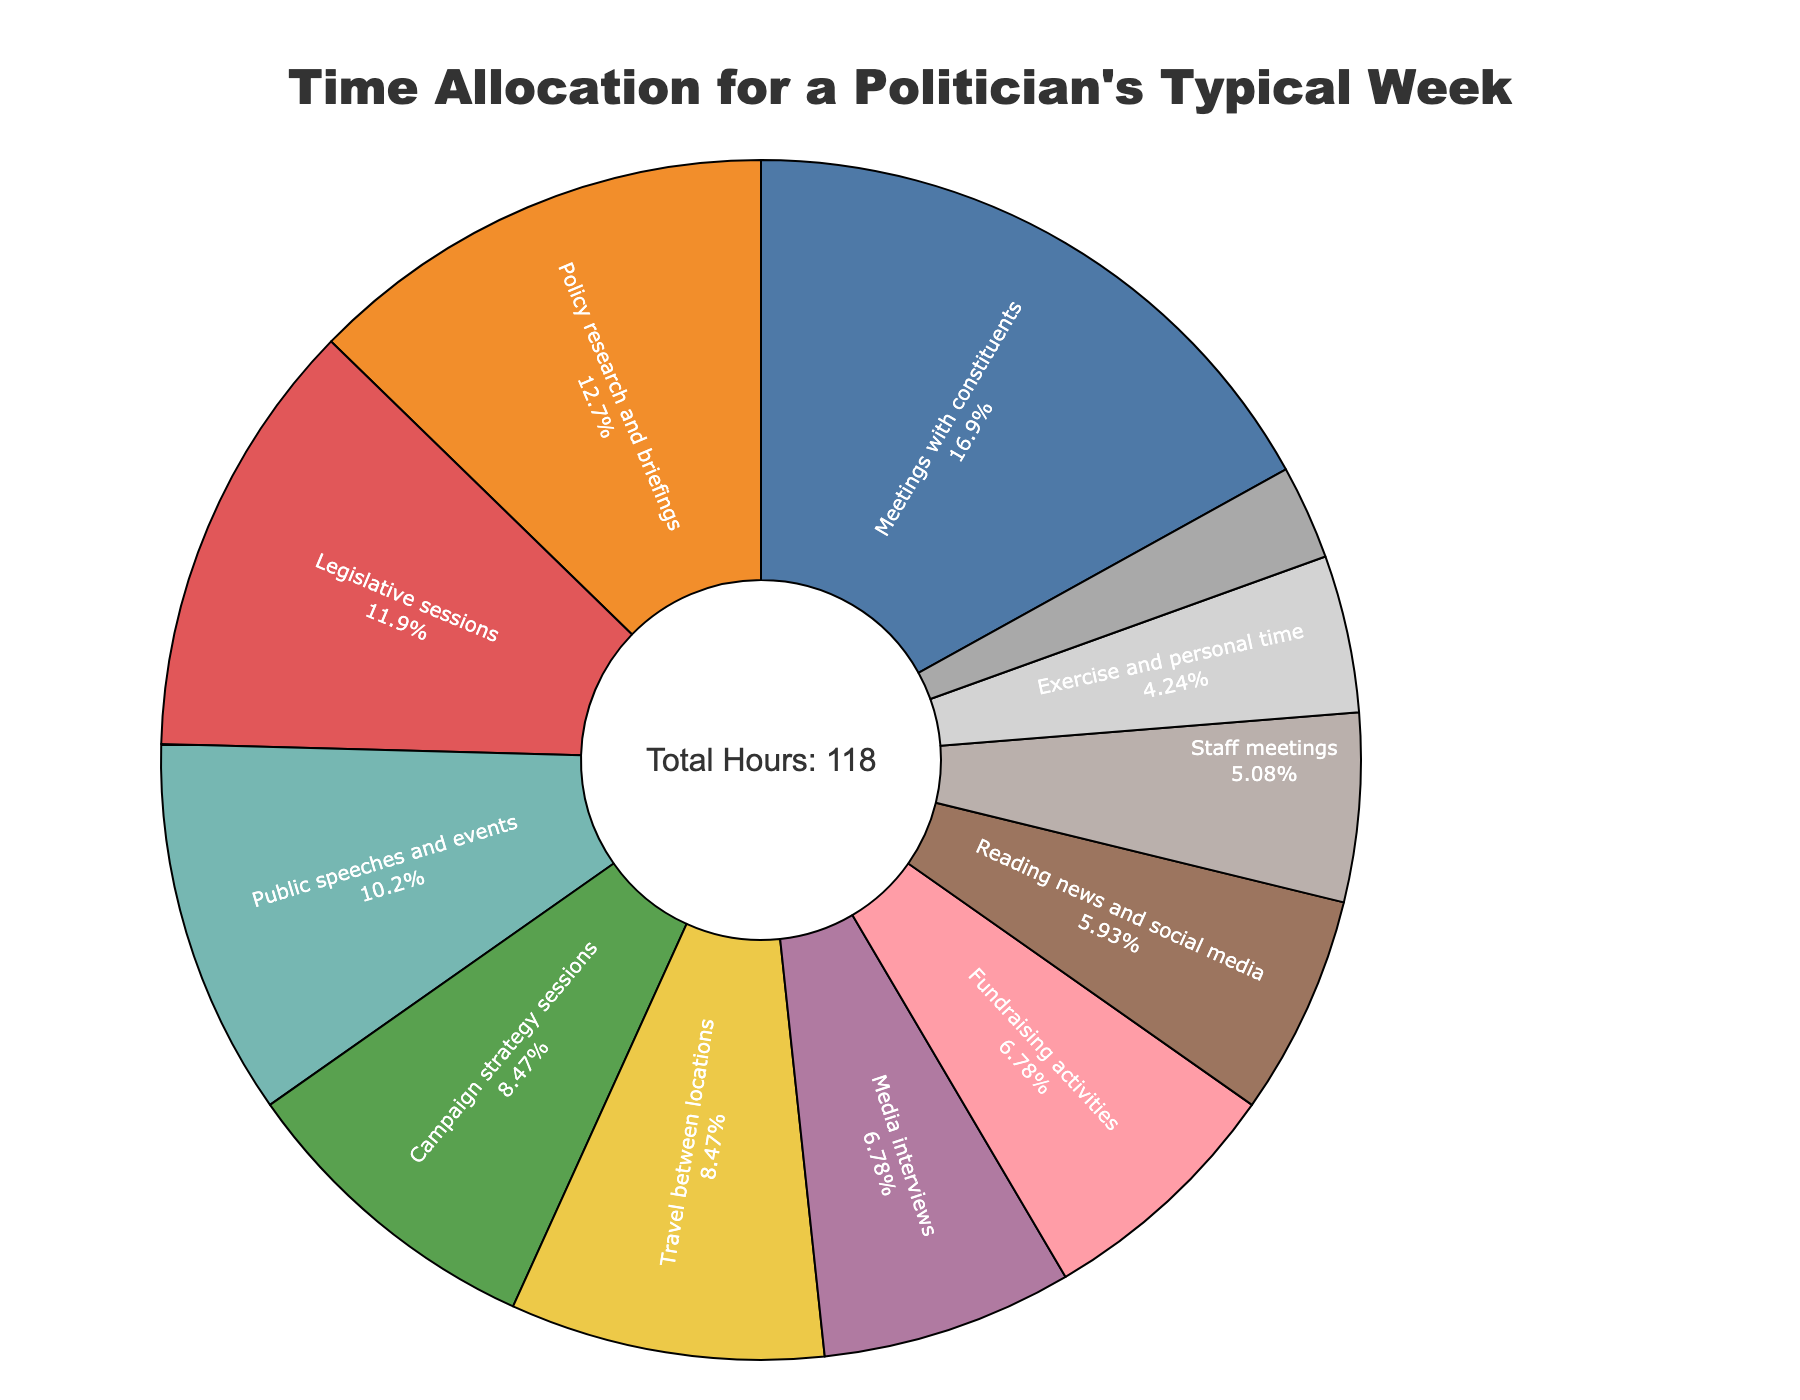What's the most time-consuming activity for a politician during the week? To find the most time-consuming activity, identify the activity with the largest portion in the pie chart. Meetings with constituents occupies the largest section.
Answer: Meetings with constituents Which activities take up the same amount of time? Look for segments in the pie chart that are equal in size. Media interviews and fundraising activities both take up the same amount of time, each 8 hours.
Answer: Media interviews and fundraising activities How many hours are spent in Campaign strategy sessions and Travel between locations combined? To get the total hours, add up the hours spent on Campaign strategy sessions and Travel between locations. From the data: 10 + 10 = 20 hours.
Answer: 20 hours What percentage of the week is spent on Legislative sessions? Look for the percentage given in the pie chart for Legislative sessions. According to the chart, the section representing Legislative sessions shows its percentage.
Answer: 11.86% Is more time spent on Public speeches and events, or on Exercise and personal time? Compare the portions in the pie chart representing Public speeches and events, and Exercise and personal time. Public speeches and events take 12 hours while Exercise and personal time take 5 hours.
Answer: Public speeches and events What's the total time allocated to Activities involving communication, such as Media interviews, Public speeches and events? Add the hours for Media interviews and Public speeches and events. From the data: 8 (Media interviews) + 12 (Public speeches and events) = 20 hours.
Answer: 20 hours In terms of time, which activity is just above Staff meetings in the pie chart? Identify the activity that occupies a slightly larger portion than Staff meetings in the pie chart. Reading news and social media is just above Staff meetings.
Answer: Reading news and social media If we combine the hours for Meetings with constituents and Policy research and briefings, how many hours do we get? Add the hours for Meetings with constituents and Policy research and briefings. From the data: 20 + 15 = 35 hours.
Answer: 35 hours What activity has a smaller time allocation than Reading news and social media, but larger than Personal grooming and haircuts? Look for the activity that has a portion between Reading news and social media (7 hours) and Personal grooming and haircuts (3 hours). Exercise and personal time with 5 hours lands between them.
Answer: Exercise and personal time 